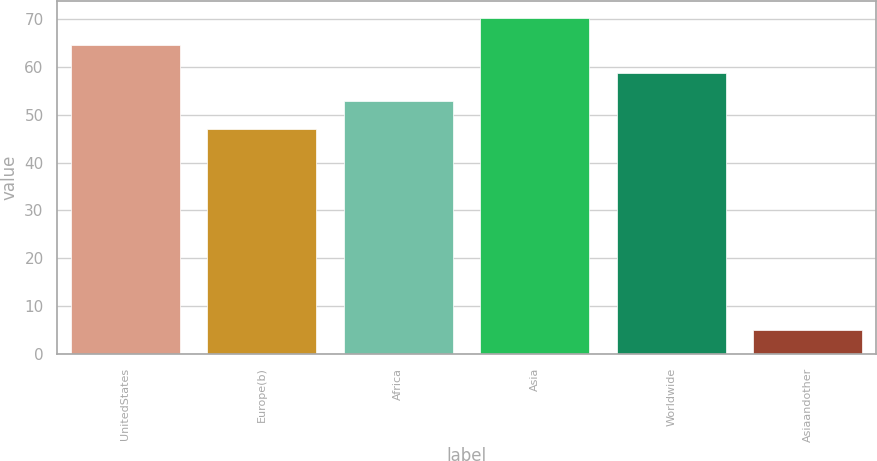<chart> <loc_0><loc_0><loc_500><loc_500><bar_chart><fcel>UnitedStates<fcel>Europe(b)<fcel>Africa<fcel>Asia<fcel>Worldwide<fcel>Asiaandother<nl><fcel>64.41<fcel>47.02<fcel>52.82<fcel>70.2<fcel>58.62<fcel>5.06<nl></chart> 